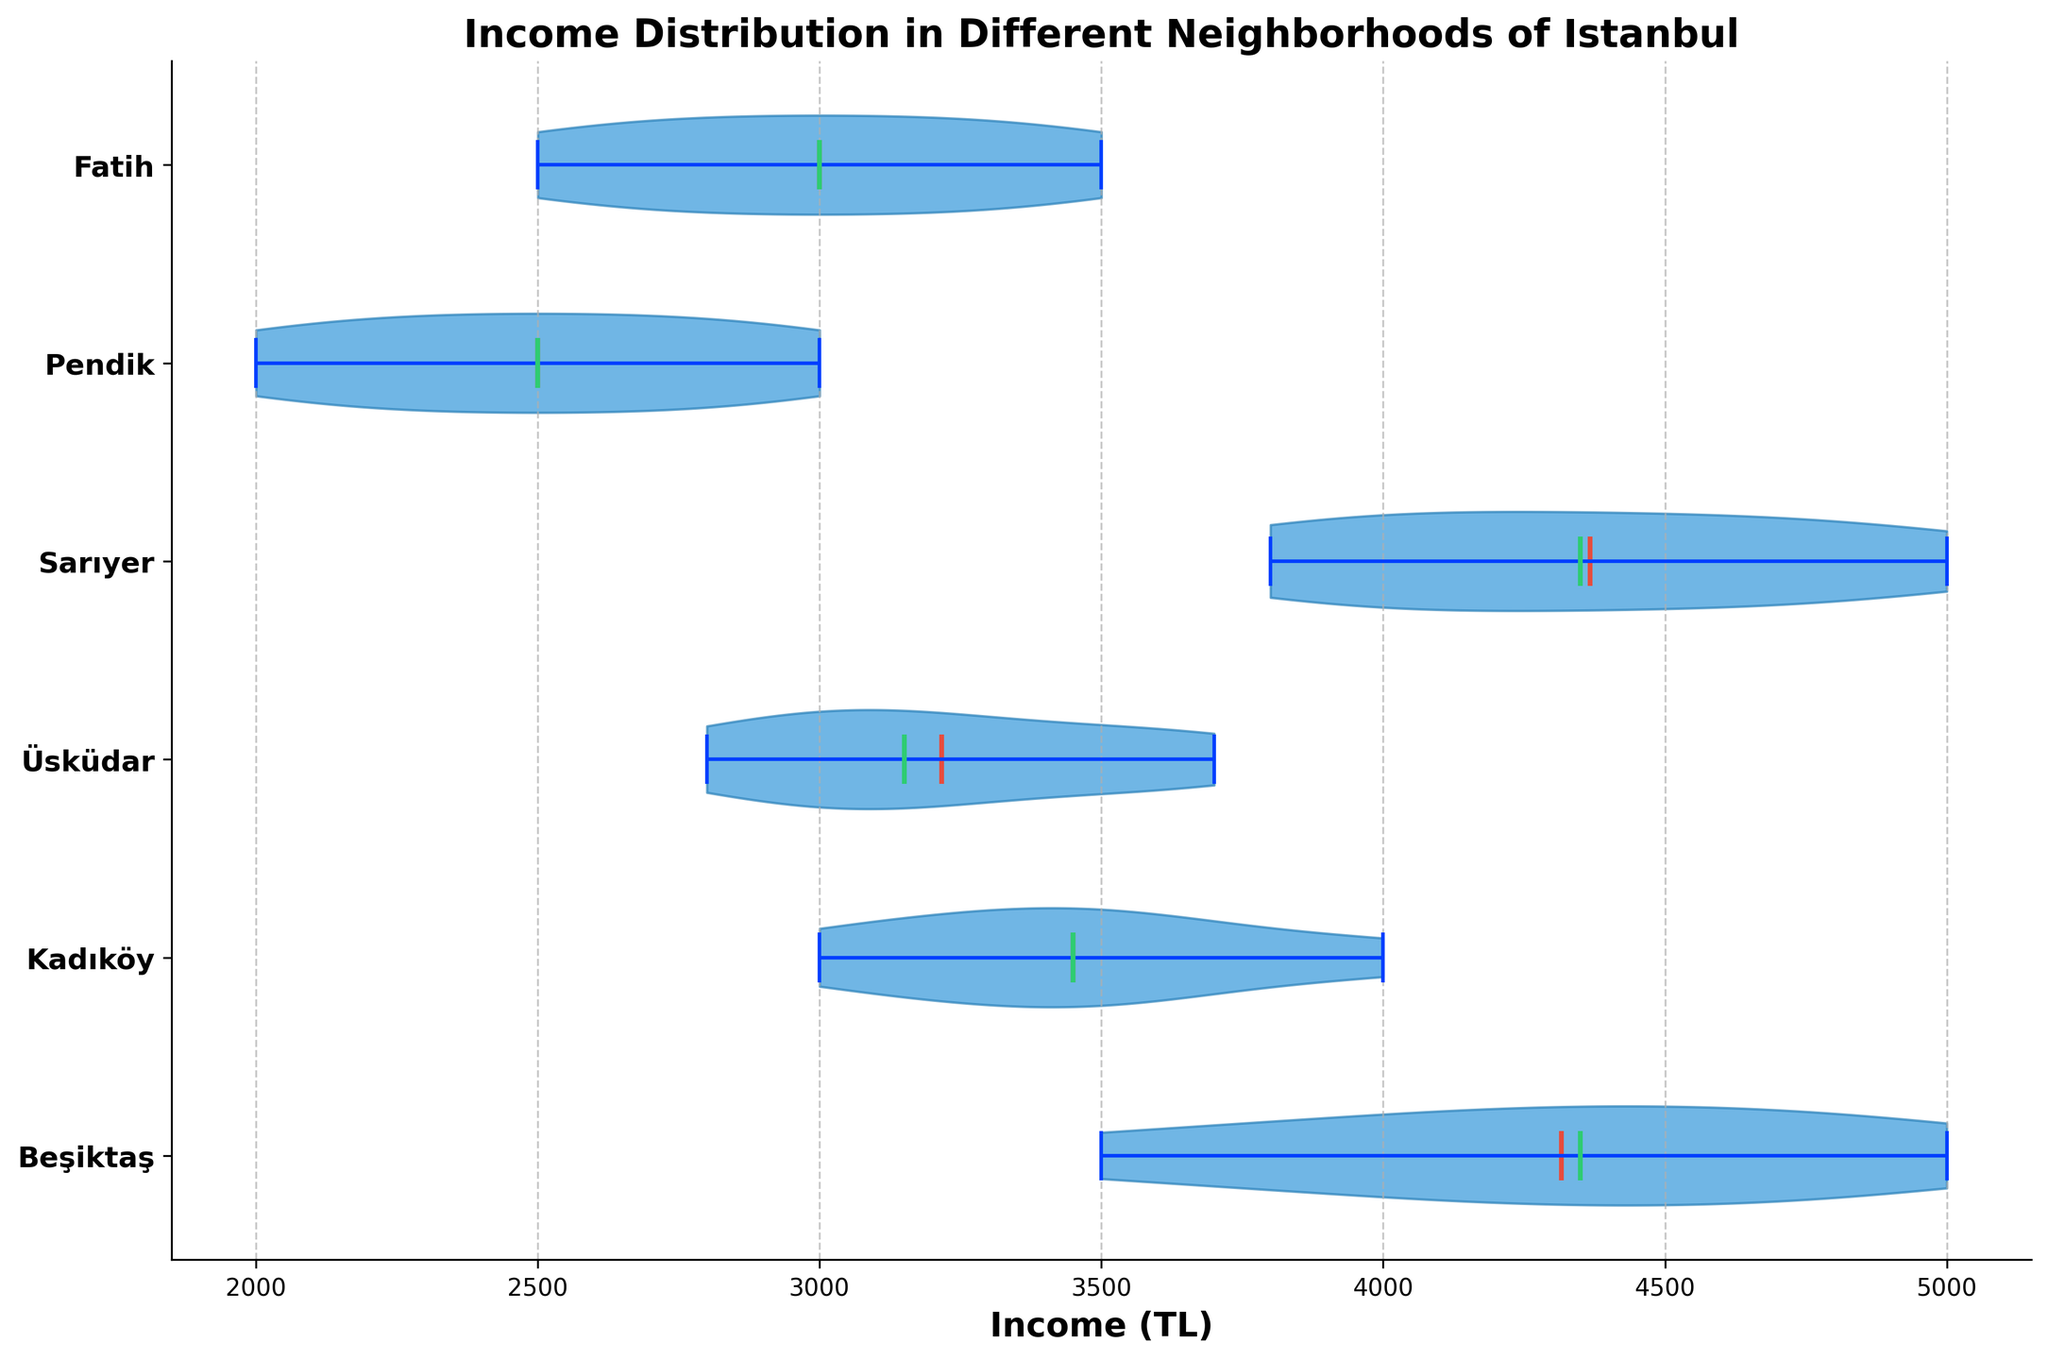What is the title of the figure? The title is written at the top of the figure.
Answer: Income Distribution in Different Neighborhoods of Istanbul Which neighborhood has the highest median income? The median income is represented by the green line within each violin plot.
Answer: Beşiktaş Which neighborhood has the widest income range? The width of the violin plot represents the distribution range.
Answer: Beşiktaş Are the means of income above or below the medians in the neighborhoods? The mean is shown by the red line with dots, and the median by the green line.
Answer: Mostly above Which neighborhood has the lowest average income? The average (mean) income is represented by the red line with dots.
Answer: Pendik How does the income distribution in Sarıyer compare to Üsküdar? Look at the shapes and spreading of the violin plots for Sarıyer and Üsküdar.
Answer: Sarıyer has a wider and higher distribution What color represents the median income in the violin plot? Medians are indicated by a specific color inside the plot.
Answer: Green Are the incomes in Kadıköy generally higher or lower than those in Fatih? Compare the positions and widths of the violin plots for Kadıköy and Fatih.
Answer: Higher Which neighborhood distributions show means that are closest to their medians? Compare the positions of the red and green lines within each neighborhood plot.
Answer: Üsküdar and Fatih What can be deduced about the income distribution in Beşiktaş? Assess the width, median, and mean of the Beşiktaş plot.
Answer: Highest and most spread out 